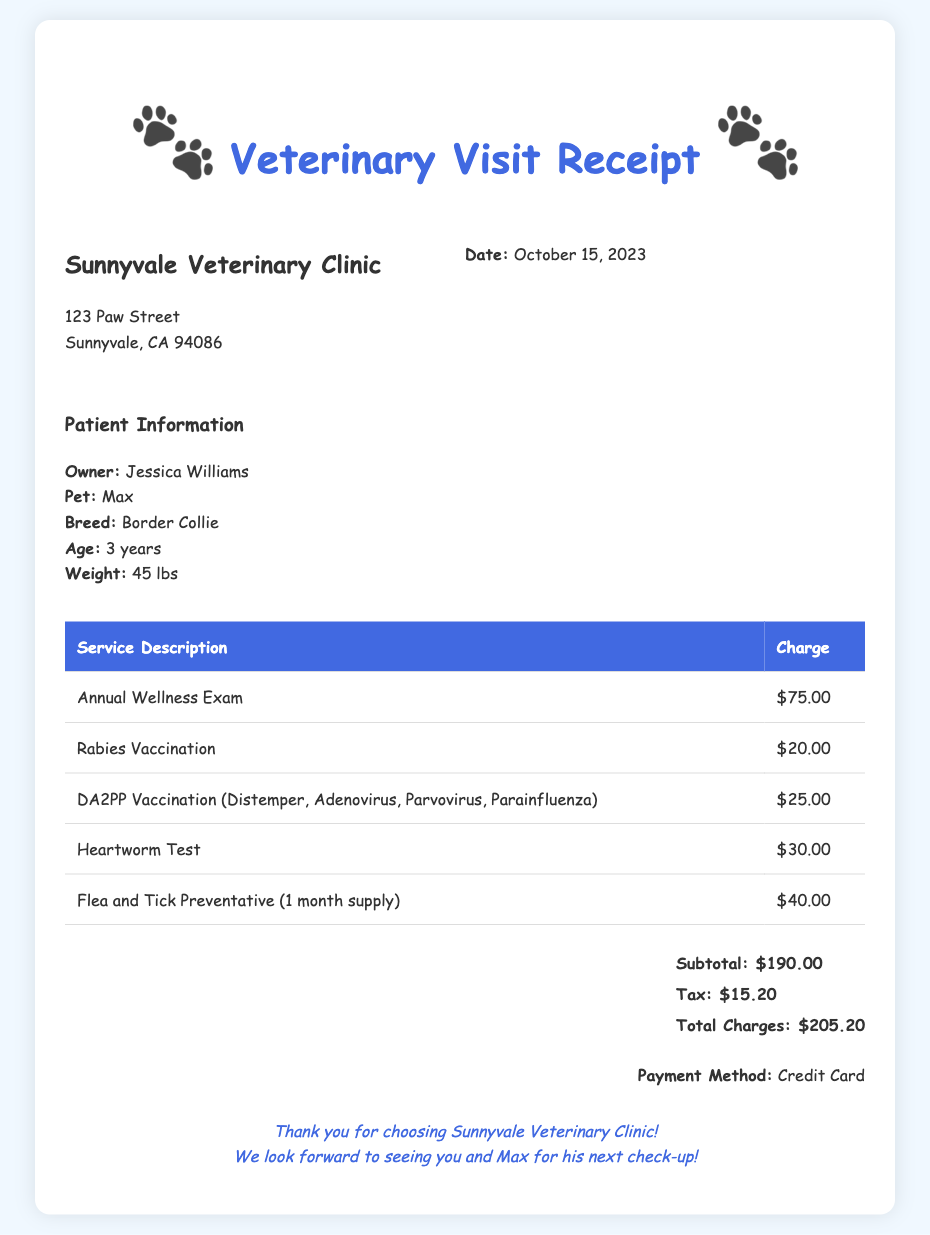What is the date of the veterinary visit? The date of the visit is stated clearly in the clinic information section of the document.
Answer: October 15, 2023 Who is the owner of the pet? The owner's name is mentioned in the patient information section of the receipt.
Answer: Jessica Williams What vaccinations were administered? The receipt lists specific vaccinations provided during the visit, including the names.
Answer: Rabies Vaccination, DA2PP Vaccination How much was charged for the Annual Wellness Exam? The charge for the Annual Wellness Exam is clearly outlined in the table of services provided.
Answer: $75.00 What is the total amount charged? The total amount is calculated in the summary section, including subtotal and tax.
Answer: $205.20 How many services were listed on the receipt? The number of services can be counted from the rows in the services table.
Answer: 5 What method of payment was used? The payment information is mentioned at the bottom of the receipt.
Answer: Credit Card What is the subtotal before tax? The subtotal is specified in the summary section of the receipt.
Answer: $190.00 What is the breed of the pet? The pet's breed is mentioned in the patient information section of the document.
Answer: Border Collie 